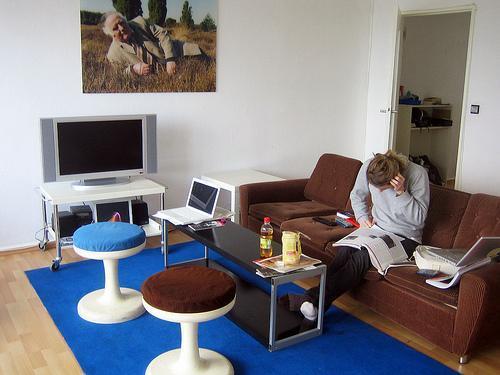How many people are in the photo?
Give a very brief answer. 1. How many laptops are in the scene?
Give a very brief answer. 1. 